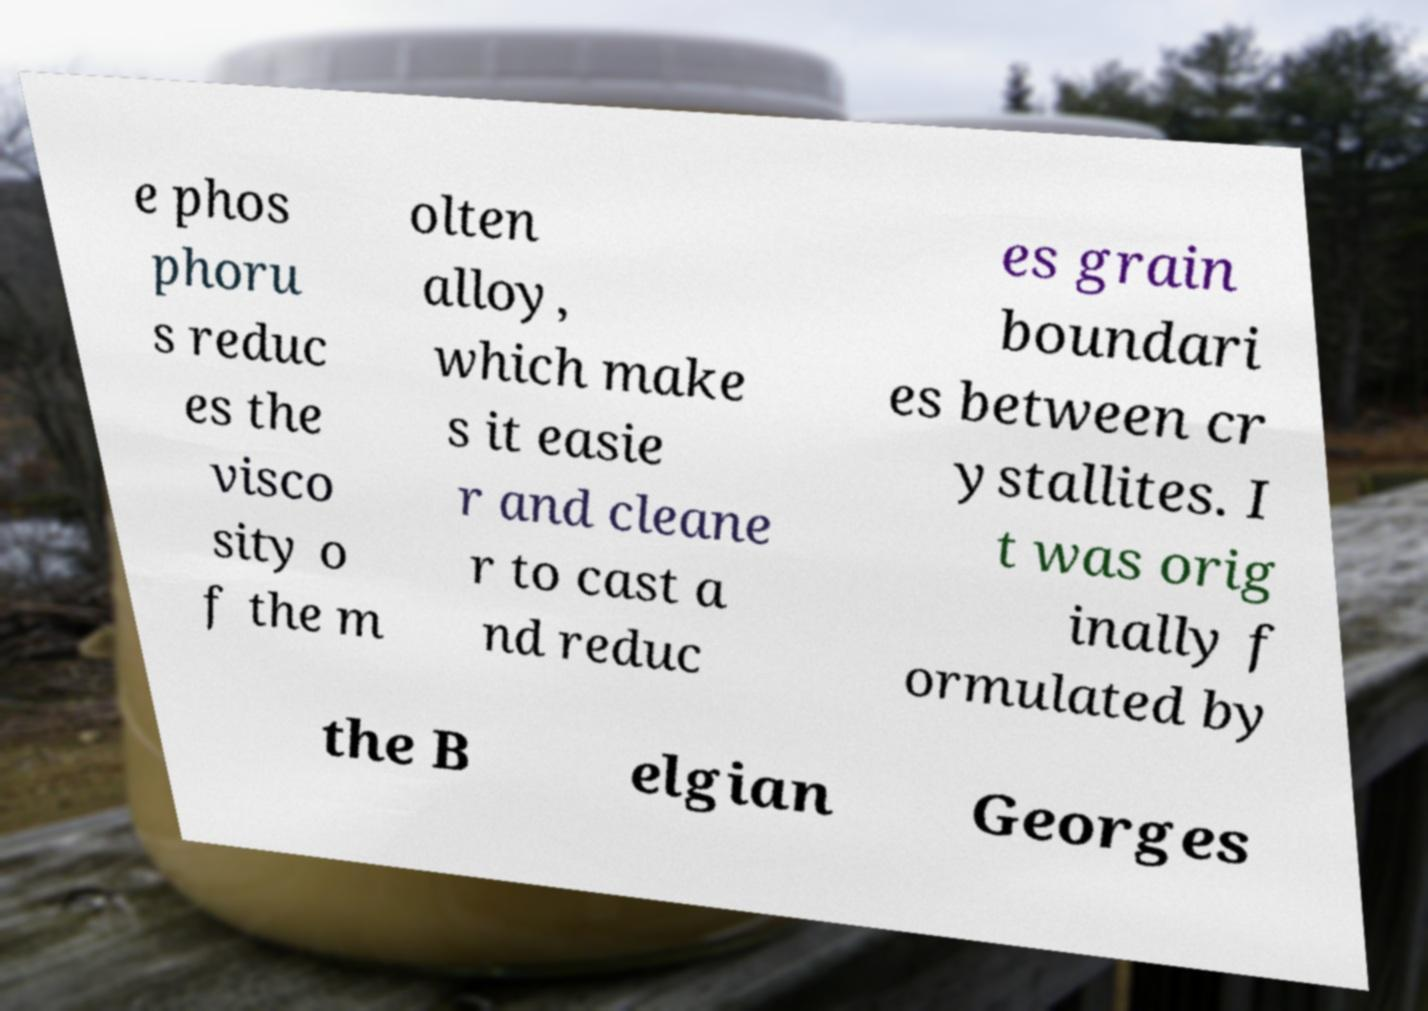For documentation purposes, I need the text within this image transcribed. Could you provide that? e phos phoru s reduc es the visco sity o f the m olten alloy, which make s it easie r and cleane r to cast a nd reduc es grain boundari es between cr ystallites. I t was orig inally f ormulated by the B elgian Georges 